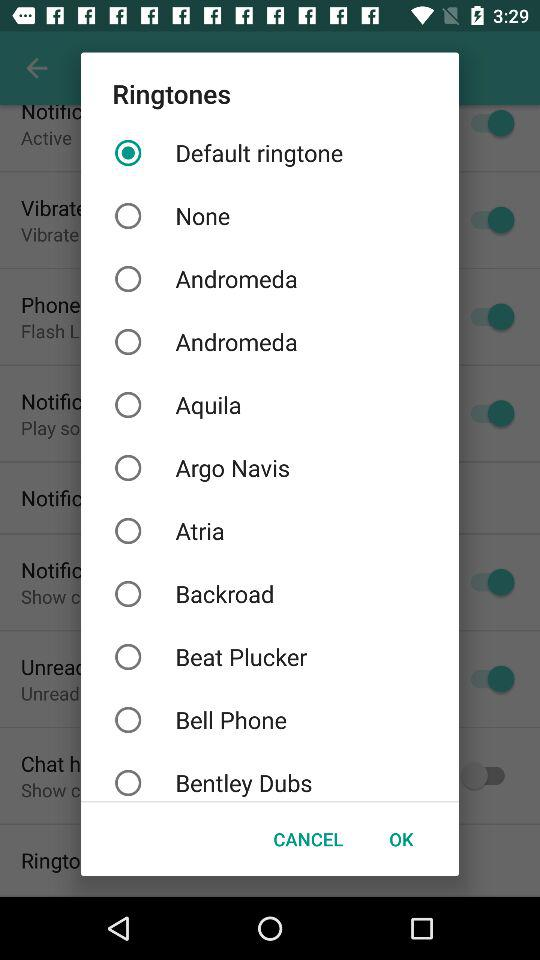What is the description of "Phone"?
When the provided information is insufficient, respond with <no answer>. <no answer> 